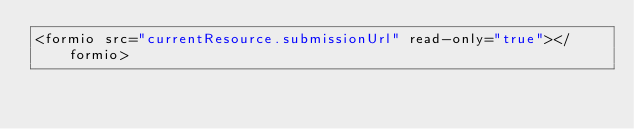<code> <loc_0><loc_0><loc_500><loc_500><_HTML_><formio src="currentResource.submissionUrl" read-only="true"></formio>
</code> 